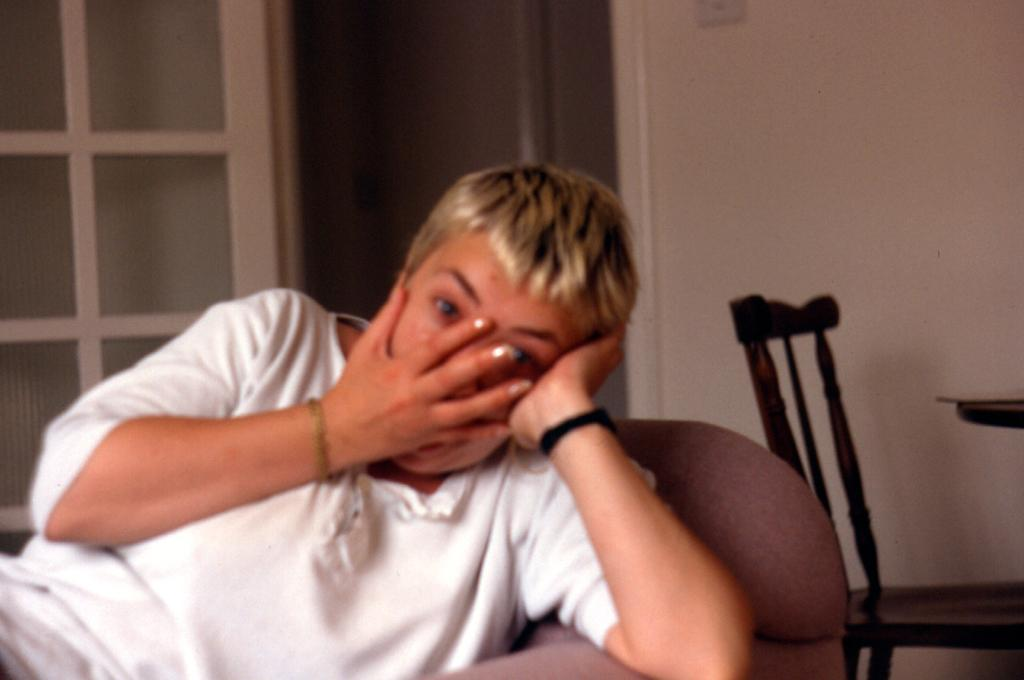What is the person in the image doing? The person is sitting on a chair. What can be seen in the background of the image? There is a door, a wall, another chair, and an object on a table in the background. What does the person's aunt request from them in the image? There is no mention of an aunt or any request in the image. 